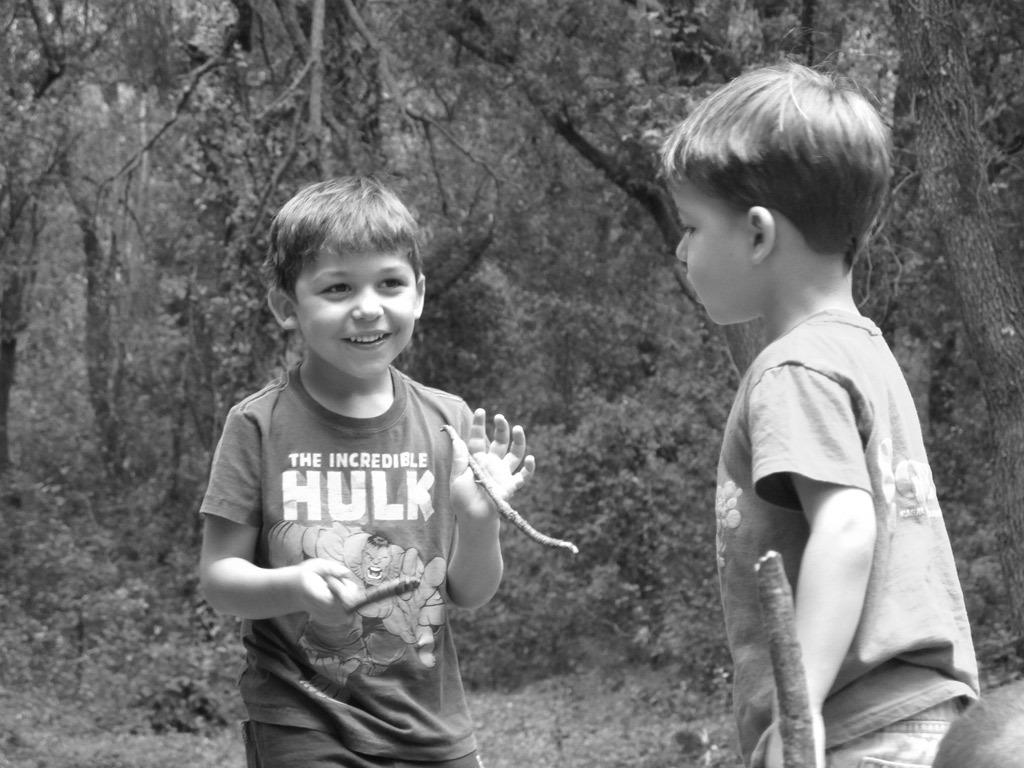What is the main subject of the image? The main subject of the image is a kid standing with two small sticks in his hands. Who is present with the kid in the image? There is another kid standing in front of him. What can be seen in the background of the image? There are trees in the background of the image. What is the title of the book the kid is reading in the image? There is no book or reading activity depicted in the image. In which month was the image taken? The provided facts do not include information about the month the image was taken. 